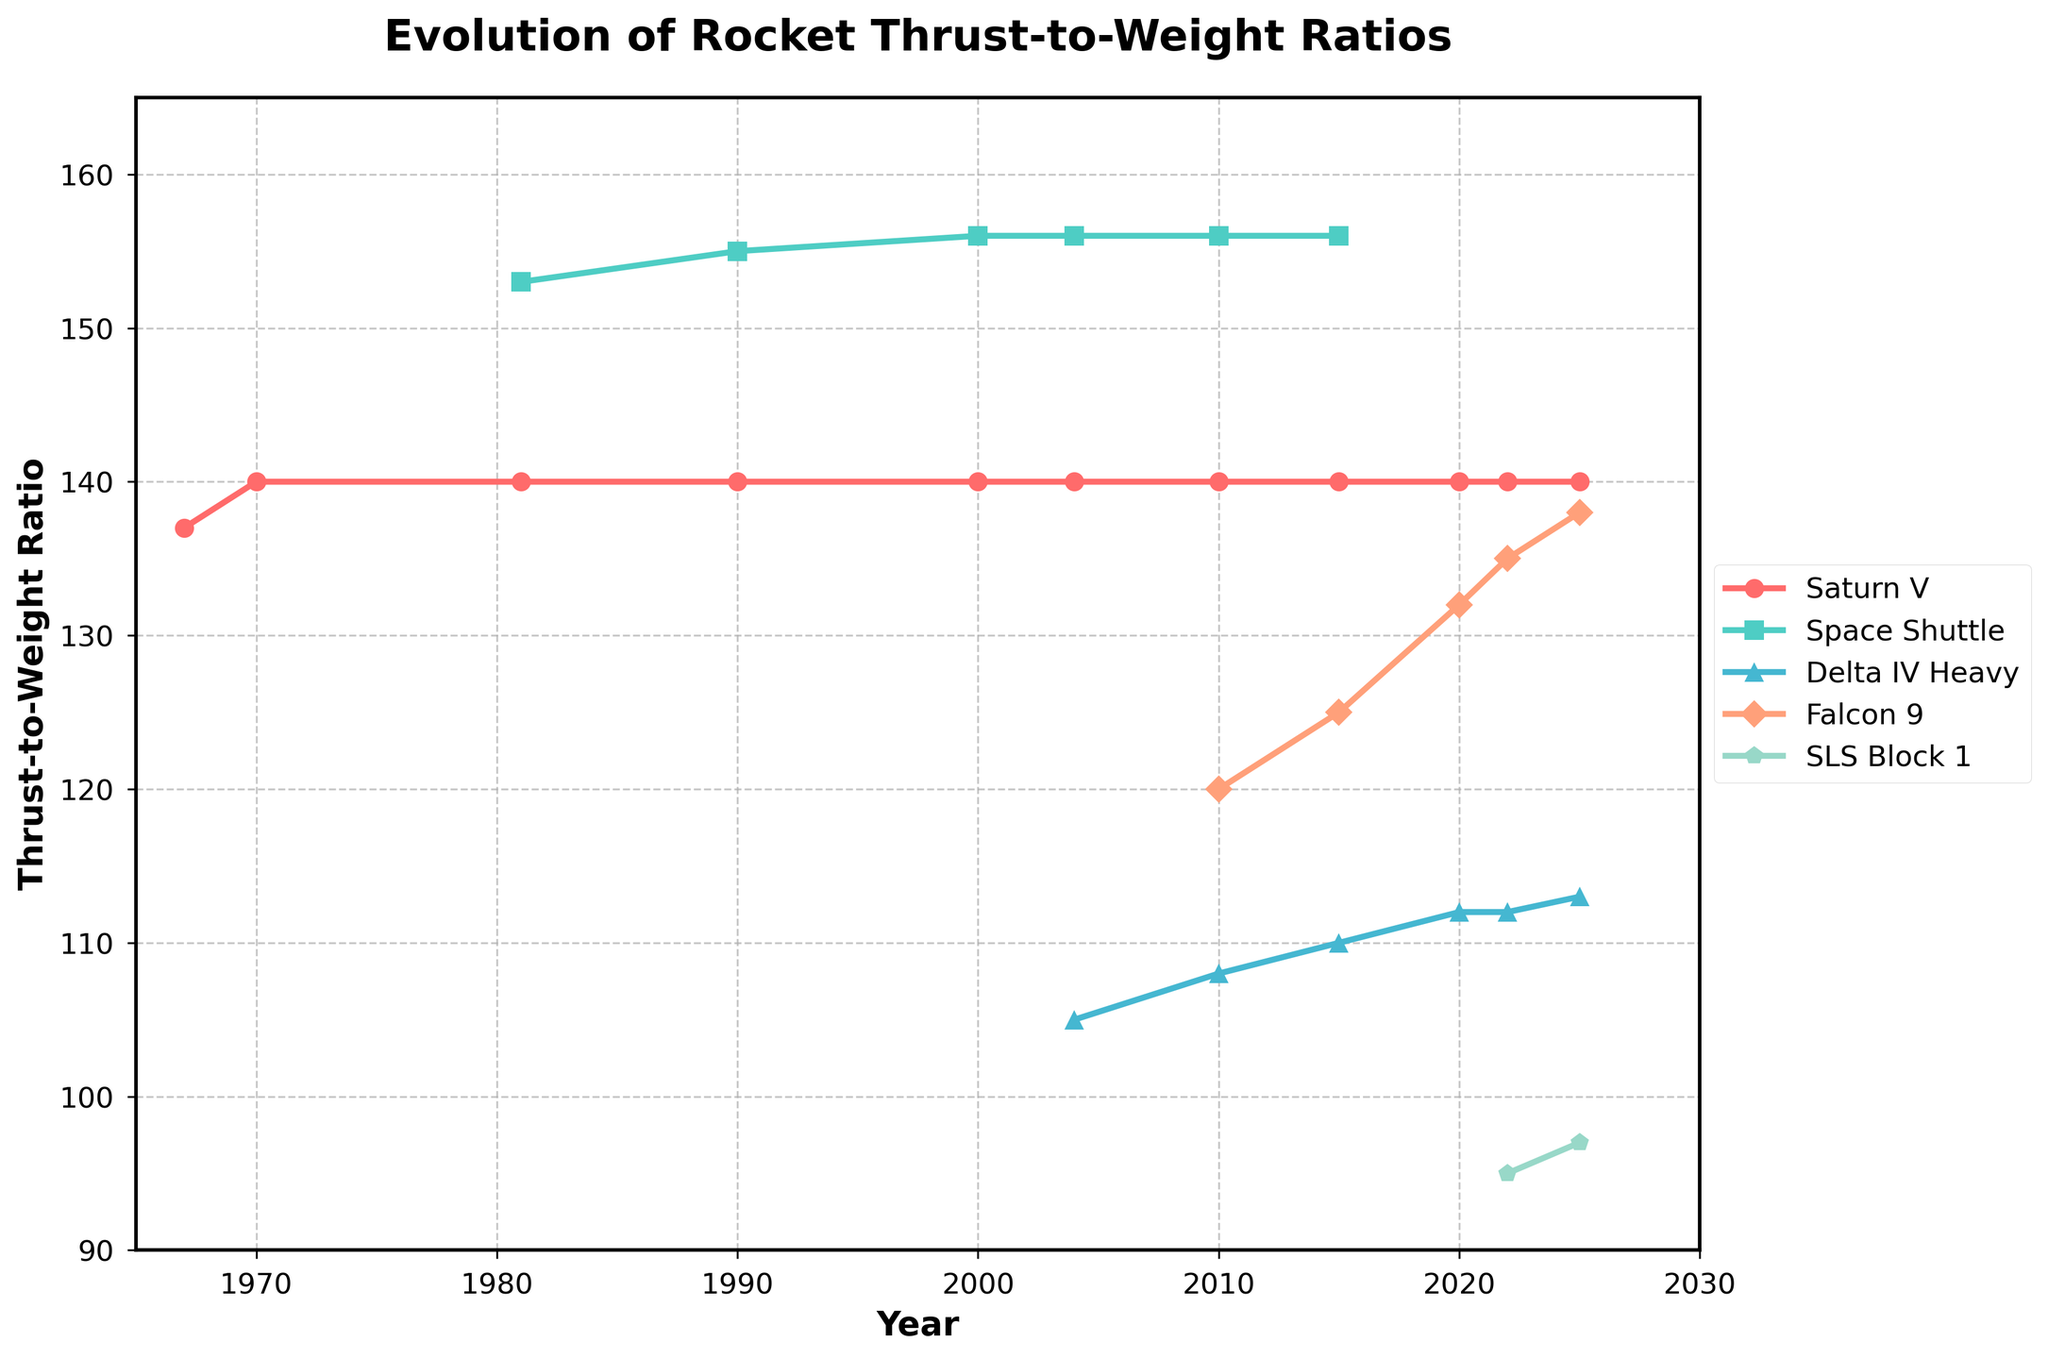What is the maximum thrust-to-weight ratio for the Saturn V in the given period? By inspecting the line corresponding to the Saturn V, we'll see that it has a maximum thrust-to-weight ratio of 140, which it holds consistently from 1970 onwards.
Answer: 140 Which rocket had the highest thrust-to-weight ratio in 2022? By examining the values for the year 2022 across all listed rockets: Saturn V (140), Falcon 9 (135), SLS Block 1 (95), we see that the Saturn V had the highest thrust-to-weight ratio in 2022.
Answer: Saturn V What was the difference in the thrust-to-weight ratio between Falcon 9 and Delta IV Heavy in 2015? Looking at the values for the year 2015, we find Falcon 9 at 125 and Delta IV Heavy at 110. Subtracting these gives 125 - 110 = 15.
Answer: 15 What is the trend for the Space Shuttle's thrust-to-weight ratio over its operational period? From the data, the Space Shuttle's thrust-to-weight ratio increases from 153 in 1981 to 156 by 2000, showing a slight upward trend during its operational years.
Answer: Increasing Between which years did the Delta IV Heavy show an increase in its thrust-to-weight ratio? Observing the Delta IV Heavy's data, it increases from 105 in 2004 to 108 in 2010, and then to 110 in 2015. Thus, there's an increase between 2004-2010 and 2010-2015.
Answer: 2004-2010 and 2010-2015 In which year did the Falcon 9 first reach a thrust-to-weight ratio of 132? Checking the data shows that Falcon 9 reached a thrust-to-weight ratio of 132 in the year 2020.
Answer: 2020 What is the average thrust-to-weight ratio of the Space Shuttle across its operational period? The values for the Space Shuttle are 153 (1981), 155 (1990), and 156 (2000). Calculating the average: (153 + 155 + 156) / 3 = 154.67.
Answer: 154.67 How many different rockets achieved a thrust-to-weight ratio above 130 at any point in time? Falcons 9 reaches above 130 in 2020 and 2022, and the Saturn V consistently holds 140 from 1970 onwards. Thus, two rockets achieved ratios above 130.
Answer: 2 